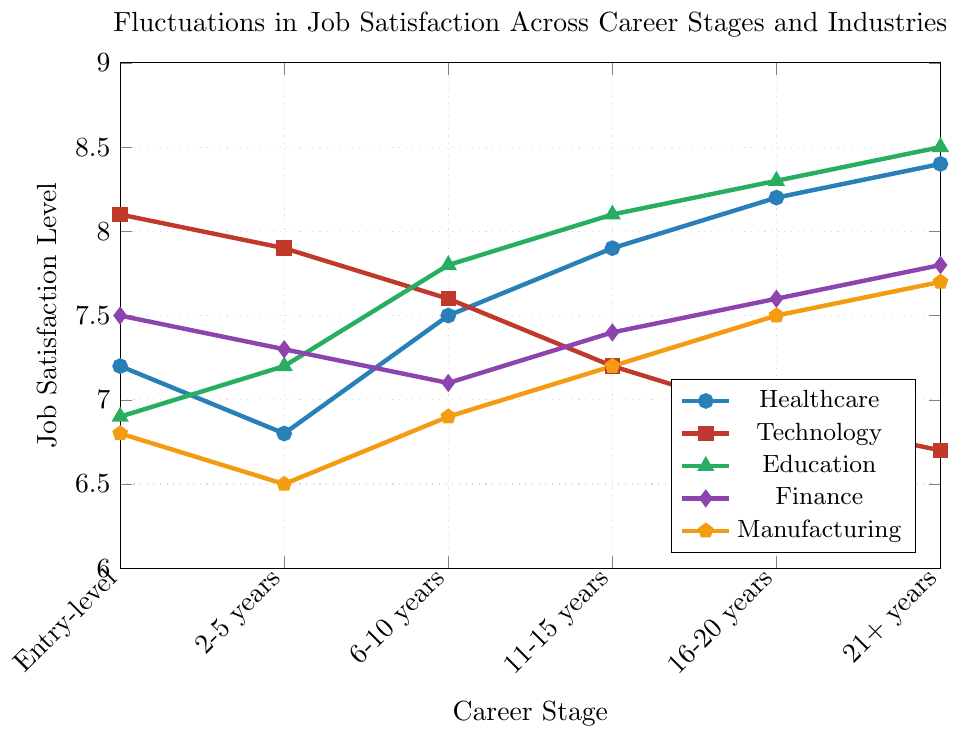What is the highest job satisfaction level in the 'Education' industry? Look at the 'Education' (green) line on the chart and identify the highest point. This occurs at 21+ years with a value of 8.5.
Answer: 8.5 Between which career stages does the 'Technology' industry experience the steepest decline in job satisfaction levels? Follow the 'Technology' (red) line and compare the slopes between each pair of points. The steepest decline is between 16-20 years and 21+ years, from 6.9 to 6.7.
Answer: 16-20 years to 21+ years Which career stage has the highest overall job satisfaction level across all industries? Compare the highest points in each career stage. The highest value across all career stages is found in the 'Education' industry at the 21+ years career stage with a job satisfaction level of 8.5.
Answer: 21+ years What is the average job satisfaction level in the 'Finance' industry? Add the job satisfaction levels for each career stage in the 'Finance' (purple) industry: 7.5, 7.3, 7.1, 7.4, 7.6, 7.8. Total is 44.7; divide by the number of career stages (6) to get an average of 7.45.
Answer: 7.45 How does the job satisfaction level in 'Manufacturing' at the entry-level compare to the 21+ years career stage? Look at the 'Manufacturing' (orange) line values at entry-level and 21+ years, which are 6.8 and 7.7 respectively. The job satisfaction level increases by 0.9 points.
Answer: 7.7 is higher Which industry shows a consistent increase in job satisfaction levels as career stages progress? Examine each industry's trend lines. The 'Education' industry (green) shows a consistent increase from 6.9 at entry-level to 8.5 at 21+ years.
Answer: Education What is the difference in job satisfaction levels between the '6-10 years' and the '11-15 years' career stages in the 'Healthcare' industry? Identify the values for 'Healthcare' (blue) at 6-10 years and 11-15 years, which are 7.5 and 7.9 respectively. Calculate the difference: 7.9 - 7.5 = 0.4.
Answer: 0.4 What trend can be observed in the 'Technology' industry over the career stages? Observe the 'Technology' (red) line. It shows a general decrease in job satisfaction levels from entry-level (8.1) to 21+ years (6.7).
Answer: Decreasing How does job satisfaction change from the 'Entry-level' to '16-20 years' in the 'Finance' industry? Observe the 'Finance' (purple) line at these two points: entry-level (7.5) and 16-20 years (7.6). There is a slight increase of 0.1 points.
Answer: Increases Calculate the job satisfaction range for 'Manufacturing' over all career stages. Find the minimum and maximum values for 'Manufacturing' (orange): 6.5 (2-5 years) and 7.7 (21+ years). The range is 7.7 - 6.5 = 1.2.
Answer: 1.2 